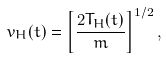<formula> <loc_0><loc_0><loc_500><loc_500>v _ { H } ( t ) = \left [ \frac { 2 T _ { H } ( t ) } { m } \right ] ^ { 1 / 2 } ,</formula> 